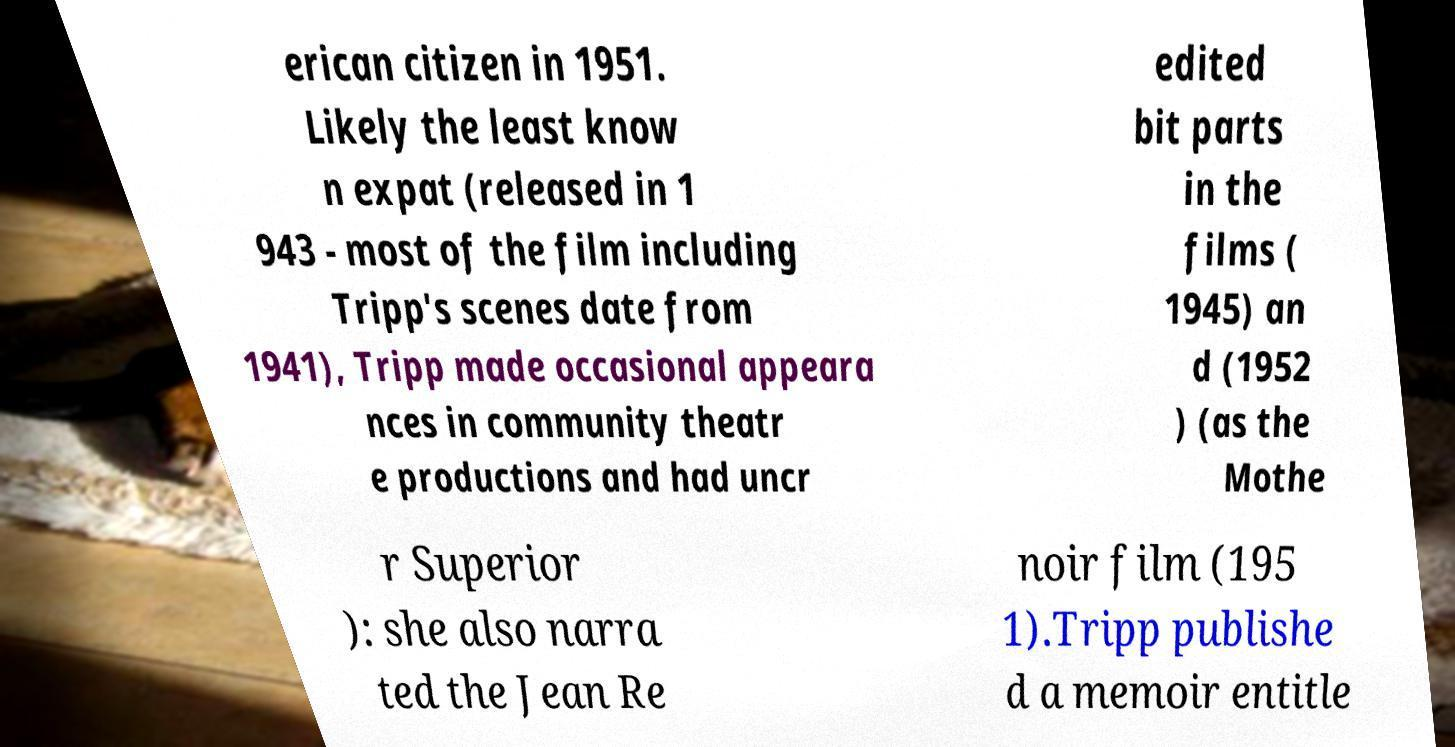Please identify and transcribe the text found in this image. erican citizen in 1951. Likely the least know n expat (released in 1 943 - most of the film including Tripp's scenes date from 1941), Tripp made occasional appeara nces in community theatr e productions and had uncr edited bit parts in the films ( 1945) an d (1952 ) (as the Mothe r Superior ): she also narra ted the Jean Re noir film (195 1).Tripp publishe d a memoir entitle 